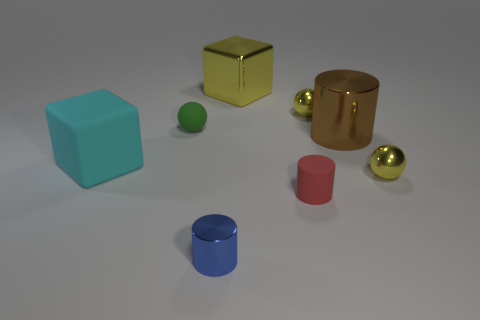Does the tiny yellow sphere behind the green rubber thing have the same material as the blue cylinder?
Your answer should be compact. Yes. The small thing right of the big cylinder has what shape?
Offer a terse response. Sphere. There is a brown cylinder that is the same size as the cyan matte thing; what is its material?
Offer a terse response. Metal. What number of objects are tiny yellow metallic things that are in front of the tiny rubber ball or balls that are in front of the small green matte ball?
Offer a very short reply. 1. The green sphere that is made of the same material as the cyan block is what size?
Provide a succinct answer. Small. What number of matte objects are blue objects or gray things?
Your answer should be compact. 0. What size is the cyan rubber block?
Keep it short and to the point. Large. Do the blue cylinder and the green matte thing have the same size?
Make the answer very short. Yes. What is the small cylinder that is in front of the red thing made of?
Provide a succinct answer. Metal. There is another large object that is the same shape as the big cyan rubber thing; what is its material?
Make the answer very short. Metal. 